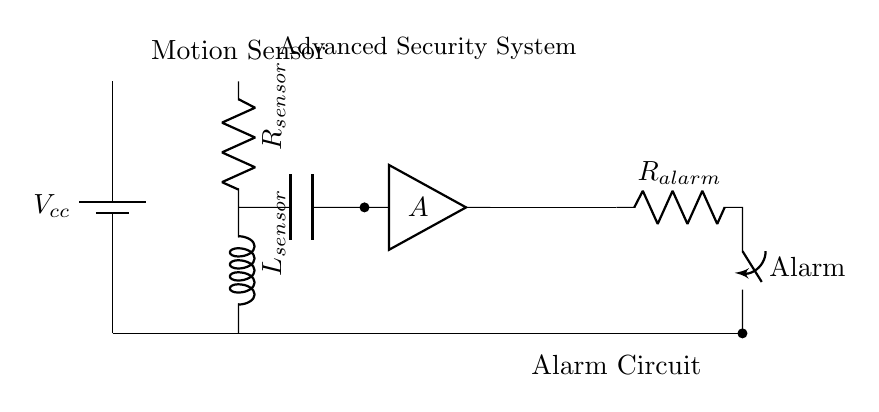what type of sensor is used in this circuit? The circuit diagram indicates a motion sensor, as labeled. This component detects motion and initiates the alarm system.
Answer: motion sensor what are the components used in the RLC circuit? The components present are a resistor, inductor, and capacitor which are typically used to filter signals or manage transient responses in circuits.
Answer: resistor, inductor, capacitor what is the purpose of the amplifier in this circuit? The amplifier boosts the signal strength from the motion sensor before it is sent to the comparator, improving detection sensitivity.
Answer: boost signal how does the alarm circuit get triggered? The alarm circuit is activated through the output from the comparator, which assesses the signal from the amplifier from the motion sensor.
Answer: through comparator what role does the inductor play in the motion sensor circuit? The inductor stores energy in a magnetic field when current passes through it, impacting the circuit's response time and behavior to changes in motion detection.
Answer: stores energy what would happen if the resistor value is increased? Increasing the resistor value results in a lower current through the circuit, which could reduce sensitivity to motion detection and affect the alarm's response time.
Answer: reduced sensitivity how do the components work together to form a security system? The motion sensor detects activity and generates a signal, which is amplified, compared, and then used to trigger the alarm circuit, creating a layered security response.
Answer: activate alarm 